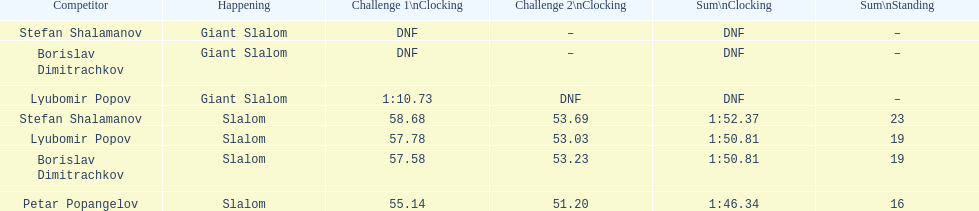How many athletes are there total? 4. 